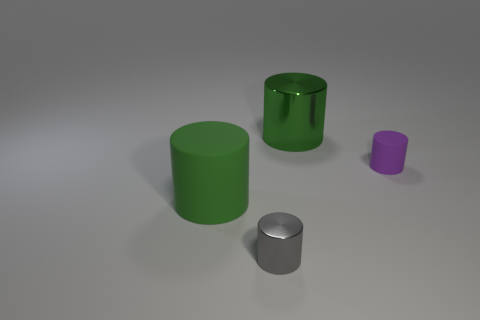There is a matte cylinder left of the big green shiny cylinder; does it have the same color as the large thing behind the big rubber object?
Offer a very short reply. Yes. There is a tiny matte thing; what number of big green matte objects are on the right side of it?
Offer a very short reply. 0. How many tiny shiny things have the same color as the large matte object?
Make the answer very short. 0. Do the green cylinder behind the tiny purple thing and the purple object have the same material?
Your answer should be very brief. No. How many purple cylinders have the same material as the gray cylinder?
Your answer should be very brief. 0. Are there more matte cylinders in front of the big matte cylinder than big metallic cylinders?
Provide a succinct answer. No. What is the size of the metallic cylinder that is the same color as the large rubber cylinder?
Make the answer very short. Large. Is there another big shiny thing that has the same shape as the large shiny thing?
Your answer should be compact. No. How many objects are gray cylinders or metal cylinders?
Give a very brief answer. 2. There is a cylinder behind the rubber object right of the green matte cylinder; how many tiny metallic objects are in front of it?
Offer a terse response. 1. 